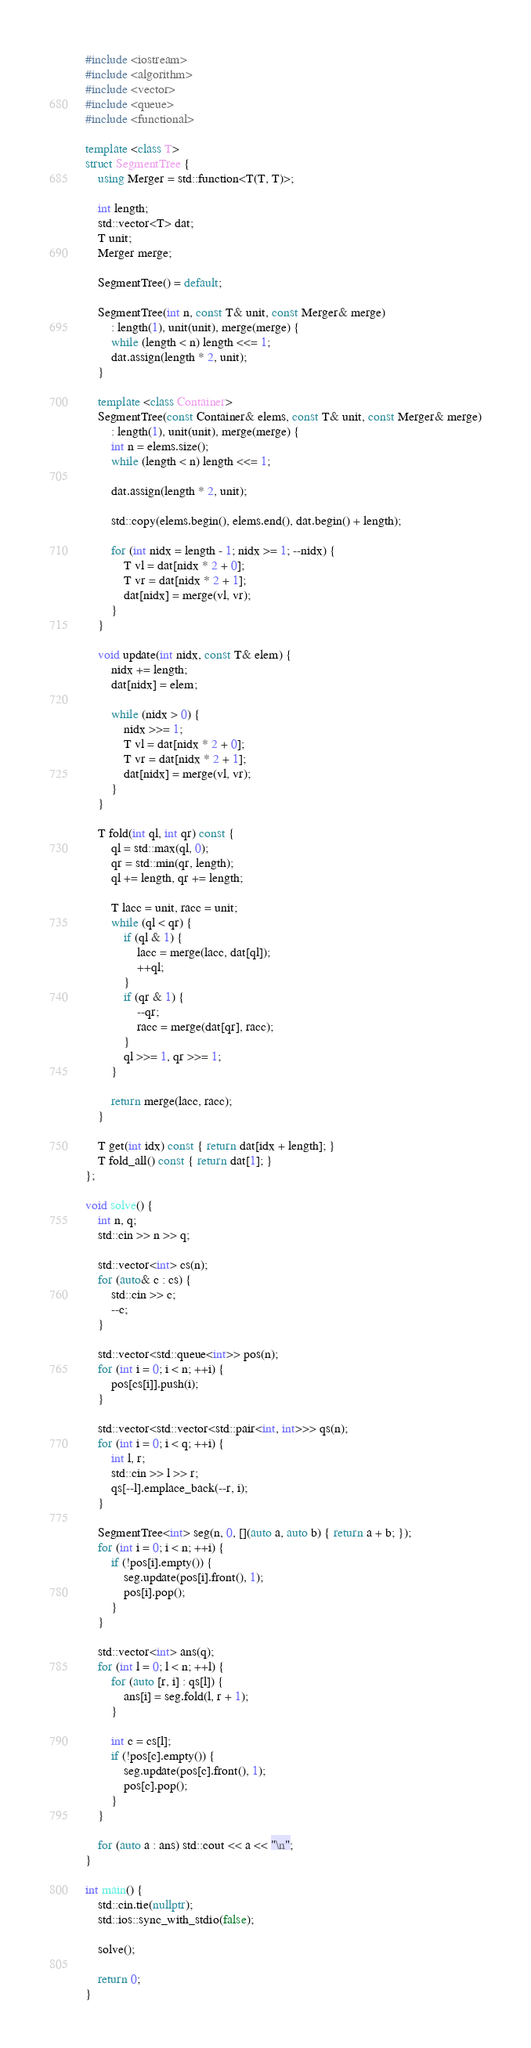<code> <loc_0><loc_0><loc_500><loc_500><_C++_>#include <iostream>
#include <algorithm>
#include <vector>
#include <queue>
#include <functional>

template <class T>
struct SegmentTree {
    using Merger = std::function<T(T, T)>;

    int length;
    std::vector<T> dat;
    T unit;
    Merger merge;

    SegmentTree() = default;

    SegmentTree(int n, const T& unit, const Merger& merge)
        : length(1), unit(unit), merge(merge) {
        while (length < n) length <<= 1;
        dat.assign(length * 2, unit);
    }

    template <class Container>
    SegmentTree(const Container& elems, const T& unit, const Merger& merge)
        : length(1), unit(unit), merge(merge) {
        int n = elems.size();
        while (length < n) length <<= 1;

        dat.assign(length * 2, unit);

        std::copy(elems.begin(), elems.end(), dat.begin() + length);

        for (int nidx = length - 1; nidx >= 1; --nidx) {
            T vl = dat[nidx * 2 + 0];
            T vr = dat[nidx * 2 + 1];
            dat[nidx] = merge(vl, vr);
        }
    }

    void update(int nidx, const T& elem) {
        nidx += length;
        dat[nidx] = elem;

        while (nidx > 0) {
            nidx >>= 1;
            T vl = dat[nidx * 2 + 0];
            T vr = dat[nidx * 2 + 1];
            dat[nidx] = merge(vl, vr);
        }
    }

    T fold(int ql, int qr) const {
        ql = std::max(ql, 0);
        qr = std::min(qr, length);
        ql += length, qr += length;

        T lacc = unit, racc = unit;
        while (ql < qr) {
            if (ql & 1) {
                lacc = merge(lacc, dat[ql]);
                ++ql;
            }
            if (qr & 1) {
                --qr;
                racc = merge(dat[qr], racc);
            }
            ql >>= 1, qr >>= 1;
        }

        return merge(lacc, racc);
    }

    T get(int idx) const { return dat[idx + length]; }
    T fold_all() const { return dat[1]; }
};

void solve() {
    int n, q;
    std::cin >> n >> q;

    std::vector<int> cs(n);
    for (auto& c : cs) {
        std::cin >> c;
        --c;
    }

    std::vector<std::queue<int>> pos(n);
    for (int i = 0; i < n; ++i) {
        pos[cs[i]].push(i);
    }

    std::vector<std::vector<std::pair<int, int>>> qs(n);
    for (int i = 0; i < q; ++i) {
        int l, r;
        std::cin >> l >> r;
        qs[--l].emplace_back(--r, i);
    }

    SegmentTree<int> seg(n, 0, [](auto a, auto b) { return a + b; });
    for (int i = 0; i < n; ++i) {
        if (!pos[i].empty()) {
            seg.update(pos[i].front(), 1);
            pos[i].pop();
        }
    }

    std::vector<int> ans(q);
    for (int l = 0; l < n; ++l) {
        for (auto [r, i] : qs[l]) {
            ans[i] = seg.fold(l, r + 1);
        }

        int c = cs[l];
        if (!pos[c].empty()) {
            seg.update(pos[c].front(), 1);
            pos[c].pop();
        }
    }

    for (auto a : ans) std::cout << a << "\n";
}

int main() {
    std::cin.tie(nullptr);
    std::ios::sync_with_stdio(false);

    solve();

    return 0;
}
</code> 